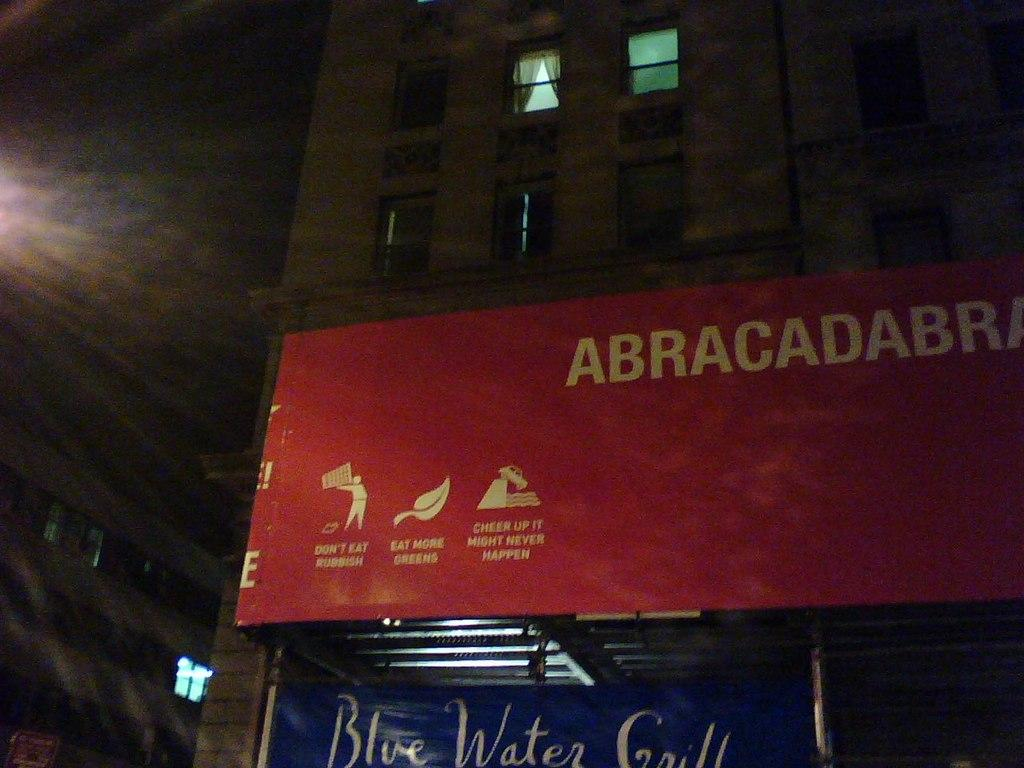<image>
Create a compact narrative representing the image presented. The canopy of a business advises people to eat more greens and not to eat rubbish. 